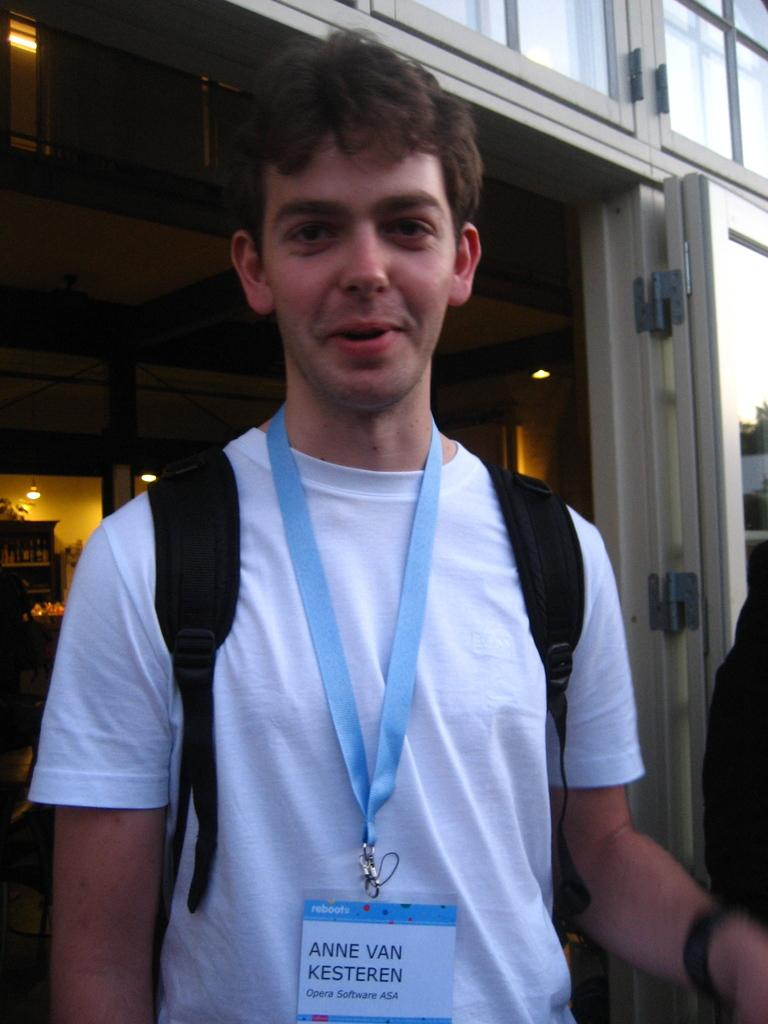Who is present in the image? There is a man in the image. What is the man doing in the image? The man is standing in the image. What can be seen on the man's clothing? The man is wearing an ID card and a white color t-shirt. What is the man's facial expression in the image? The man is smiling in the image. What is visible behind the man? There appears to be an entrance behind the man. How many trees can be seen in the image? There are no trees visible in the image. What time of day is it in the image, based on the hour? The provided facts do not mention the time of day or any specific hour, so it cannot be determined from the image. 